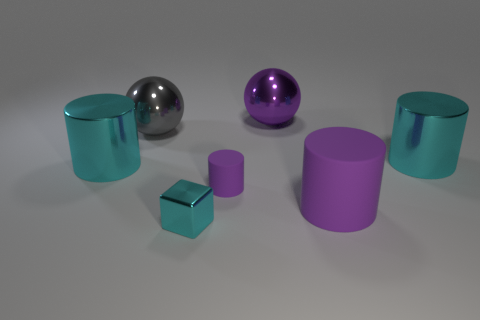Subtract all big purple cylinders. How many cylinders are left? 3 Subtract all gray blocks. How many cyan cylinders are left? 2 Add 3 big rubber cylinders. How many objects exist? 10 Subtract all red cylinders. Subtract all red blocks. How many cylinders are left? 4 Add 6 yellow cylinders. How many yellow cylinders exist? 6 Subtract 0 yellow balls. How many objects are left? 7 Subtract all cylinders. How many objects are left? 3 Subtract all tiny blue matte cylinders. Subtract all tiny purple things. How many objects are left? 6 Add 3 large gray balls. How many large gray balls are left? 4 